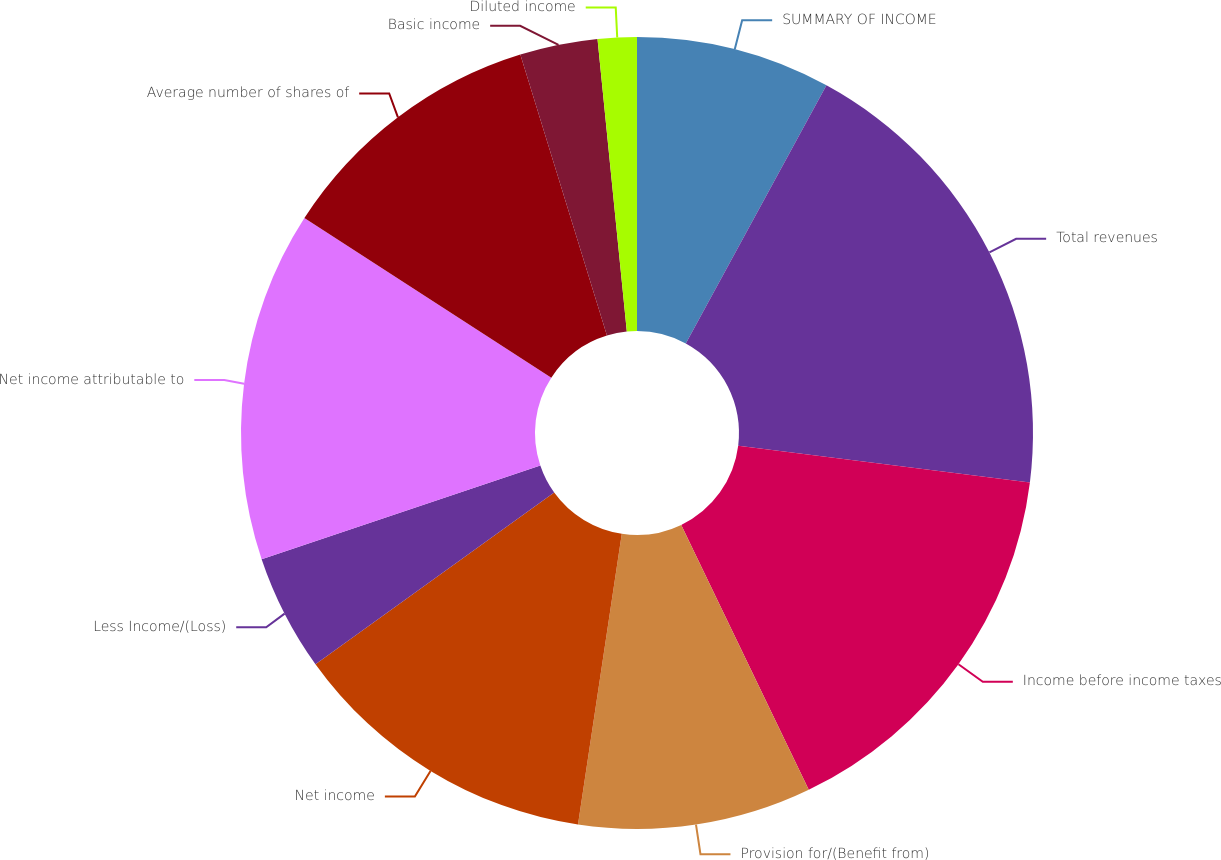<chart> <loc_0><loc_0><loc_500><loc_500><pie_chart><fcel>SUMMARY OF INCOME<fcel>Total revenues<fcel>Income before income taxes<fcel>Provision for/(Benefit from)<fcel>Net income<fcel>Less Income/(Loss)<fcel>Net income attributable to<fcel>Average number of shares of<fcel>Basic income<fcel>Diluted income<nl><fcel>7.94%<fcel>19.05%<fcel>15.87%<fcel>9.52%<fcel>12.7%<fcel>4.76%<fcel>14.29%<fcel>11.11%<fcel>3.17%<fcel>1.59%<nl></chart> 